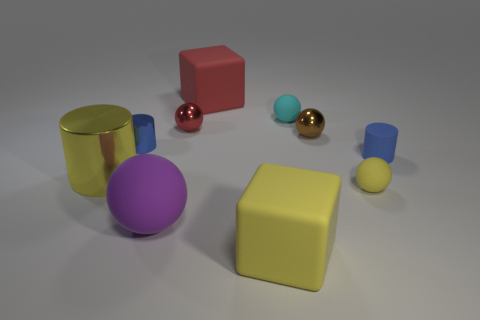What size is the yellow metal thing that is the same shape as the small blue shiny thing?
Offer a very short reply. Large. How many large matte blocks are in front of the yellow object that is to the right of the small brown metallic sphere?
Your answer should be compact. 1. There is a matte sphere that is behind the yellow metal cylinder; is its size the same as the red thing that is behind the small red metallic ball?
Ensure brevity in your answer.  No. What number of tiny shiny balls are there?
Your answer should be compact. 2. What number of other big objects have the same material as the cyan object?
Your answer should be compact. 3. Are there the same number of small brown shiny spheres that are on the left side of the small metal cylinder and small brown matte cylinders?
Your response must be concise. Yes. There is a tiny ball that is the same color as the big cylinder; what is its material?
Offer a terse response. Rubber. There is a purple matte object; does it have the same size as the blue cylinder that is on the right side of the red sphere?
Your response must be concise. No. How many other objects are the same size as the brown metallic ball?
Your answer should be very brief. 5. What number of other things are the same color as the tiny metal cylinder?
Ensure brevity in your answer.  1. 